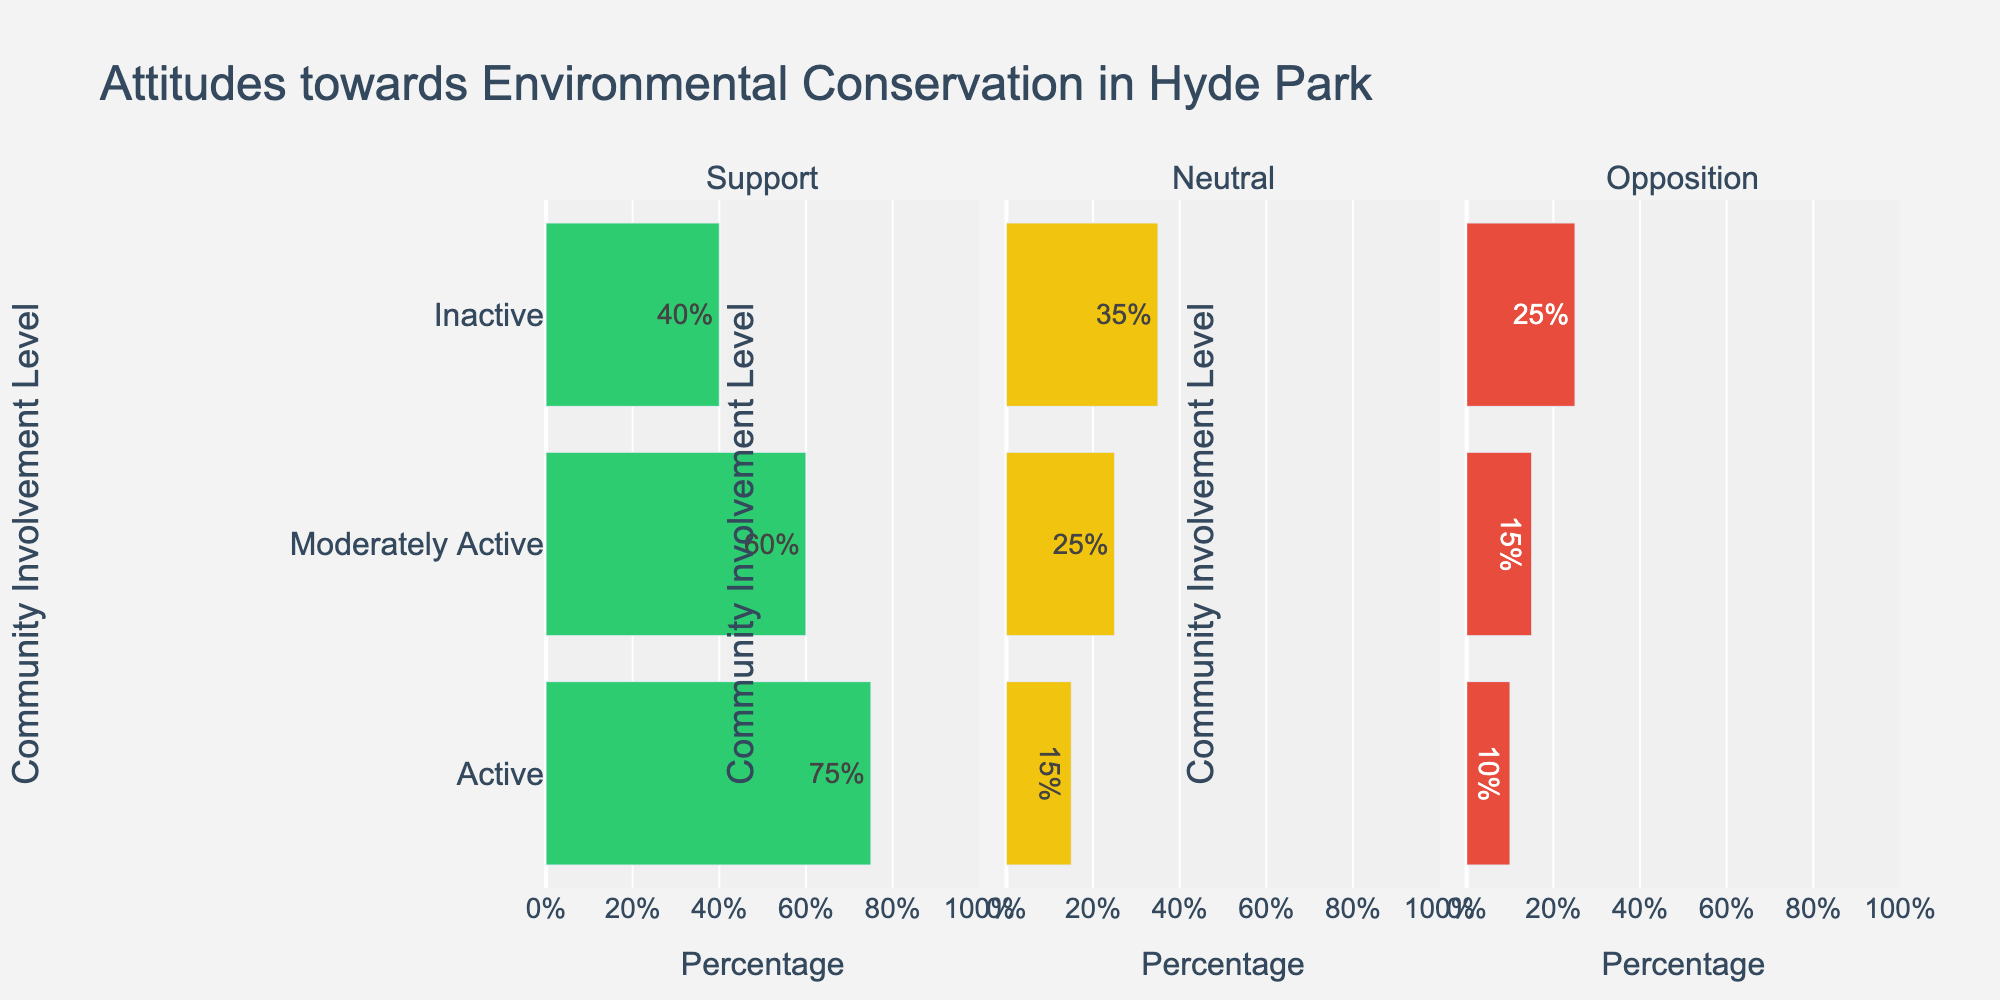What is the percentage difference in support for conservation between Active and Inactive groups? To find the percentage difference between two groups, subtract the support percentage of the Inactive group (40%) from the support percentage of the Active group (75%). 75% - 40% = 35%
Answer: 35% Which group shows the highest level of opposition towards conservation efforts? By comparing the opposition percentages for the three groups, Active (10%), Moderately Active (15%), and Inactive (25%), the Inactive group has the highest opposition at 25%.
Answer: Inactive What is the combined percentage of individuals Neutral or Opposed to conservation in the Moderately Active group? Add the Neutral percentage (25%) to the Opposition percentage (15%) for the Moderately Active group. 25% + 15% = 40%
Answer: 40% How does the Neutral attitude towards conservation compare between Active and Inactive groups? Compare the Neutral percentages between Active (15%) and Inactive (35%) groups. 35% is higher than 15%, so Inactive has a higher Neutral percentage.
Answer: Inactive has a higher Neutral percentage What is the range of support for conservation across the three groups? The range is found by subtracting the minimum support percentage (40% for Inactive) from the maximum support percentage (75% for Active). 75% - 40% = 35%
Answer: 35% Which group has the smallest percentage of individuals Neutral towards conservation? By examining the Neutral percentages, Active has 15%, Moderately Active has 25%, and Inactive has 35%. The smallest percentage is 15%.
Answer: Active What is the average percentage of Neutral attitudes towards conservation across all groups? To find the average, add the Neutral percentages (15% for Active, 25% for Moderately Active, 35% for Inactive) and divide by the number of groups, which is 3. (15% + 25% + 35%) / 3 = 25%
Answer: 25% How much greater is the percentage of Active supporters compared to Moderately Active supporters? Subtract the percentage of Moderately Active supporters (60%) from Active supporters (75%). 75% - 60% = 15%
Answer: 15% What visual color represents the Support for conservation in the chart? In examining the chart, the color used for Support bars is green.
Answer: Green What is the total percentage of Non-support (Neutral + Opposition) in the Inactive group? Sum the Neutral (35%) and Opposition (25%) percentages for the Inactive group. 35% + 25% = 60%
Answer: 60% 